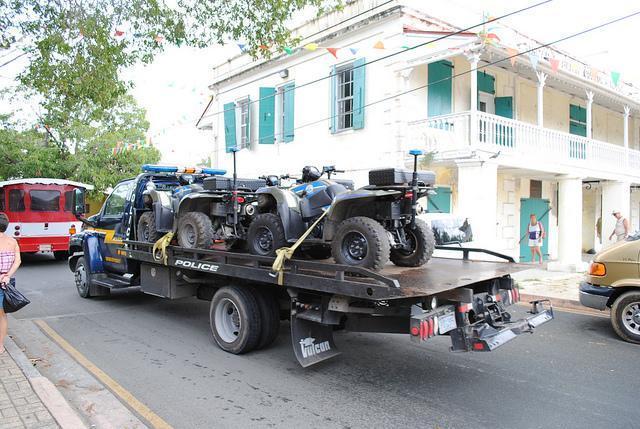How many red chairs here?
Give a very brief answer. 0. 